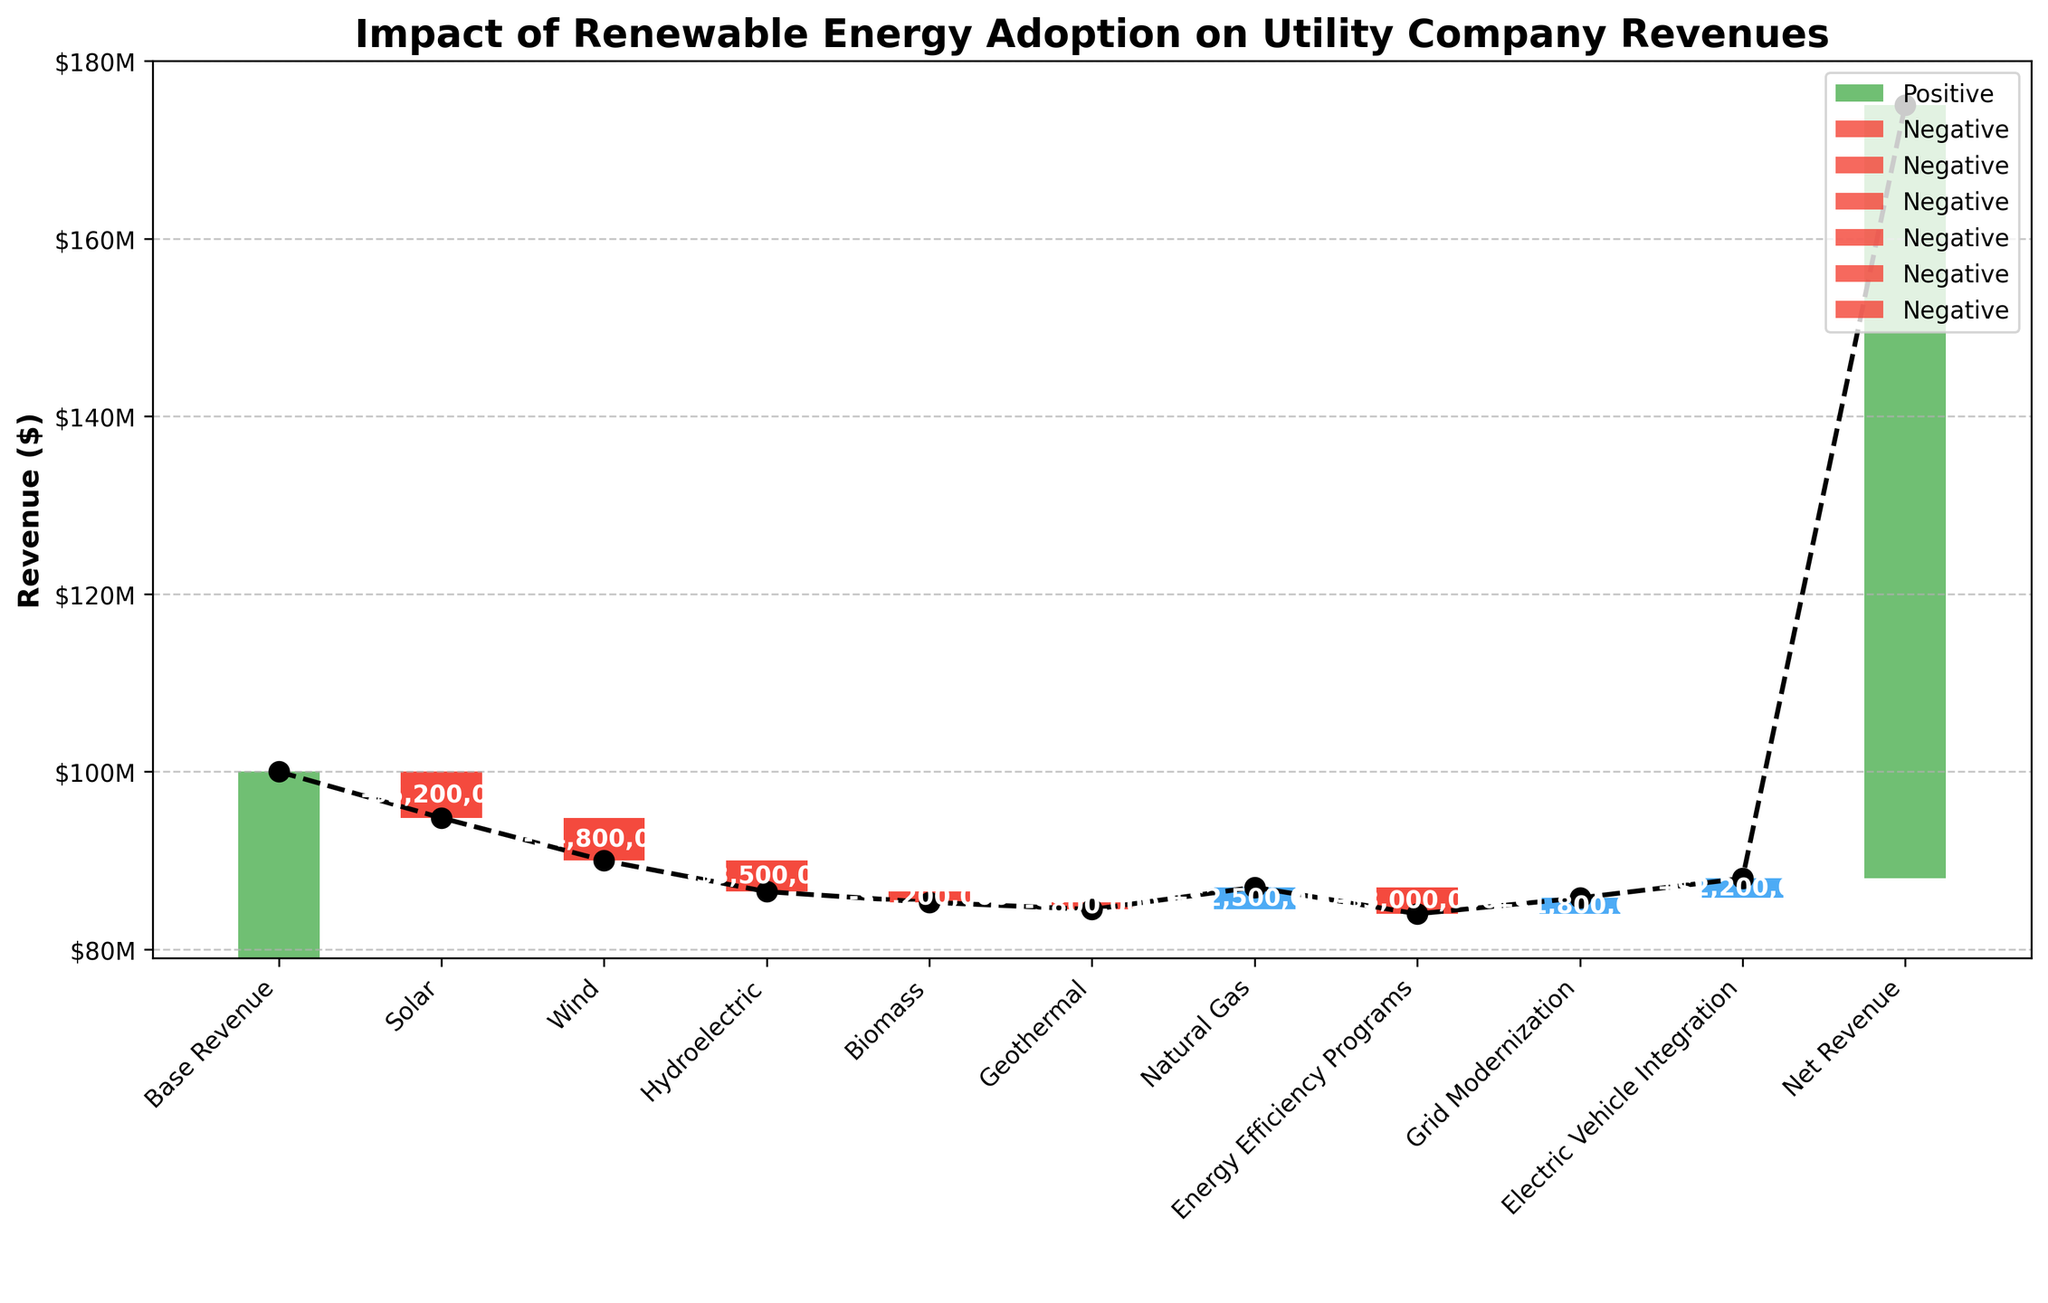What is the title of the figure? The title is usually found at the top of the figure and summarizes what the figure displays.
Answer: Impact of Renewable Energy Adoption on Utility Company Revenues How much revenue is lost due to the adoption of solar energy? Locate the bar corresponding to 'Solar' and note its value, which represents the revenue change due to solar energy.
Answer: $-5,200,000 What are the cumulative revenues after accounting for wind energy adoption? Find the position of wind energy in the sequence, calculate the combined effect of base revenue and the solar factor, then add the wind energy effect.
Answer: $90,800,000 Which renewable energy source produces the least reduction in revenue? Compare all negative impacts of renewable energy sources and identify the smallest absolute value.
Answer: Geothermal How do the values for 'Electric Vehicle Integration' and 'Grid Modernization' compare? Examine both values and determine their relationship.
Answer: Electric Vehicle Integration is greater than Grid Modernization What is the new cumulative revenue after considering all factors? The final bar represents the Net Revenue after all changes; read this value.
Answer: $87,000,000 By how much does natural gas impact the revenue, and what is its direction? Identify the value of natural gas and determine whether it is positive or negative.
Answer: $2,500,000, positive If you summed the impacts of solar, wind, and hydroelectric, what would the result be? Calculate Solar + Wind + Hydroelectric: -5,200,000 + -4,800,000 + -3,500,000.
Answer: $-13,500,000 What is the cumulative revenue before accounting for effects like 'Electric Vehicle Integration' and 'Grid Modernization'? To get the cumulative value before these, sum all prior changes starting from the base revenue.
Answer: $85,000,000 Which factor has the second largest positive impact on the revenue? From the list of positive impacts, identify which one is the second highest.
Answer: Electric Vehicle Integration 